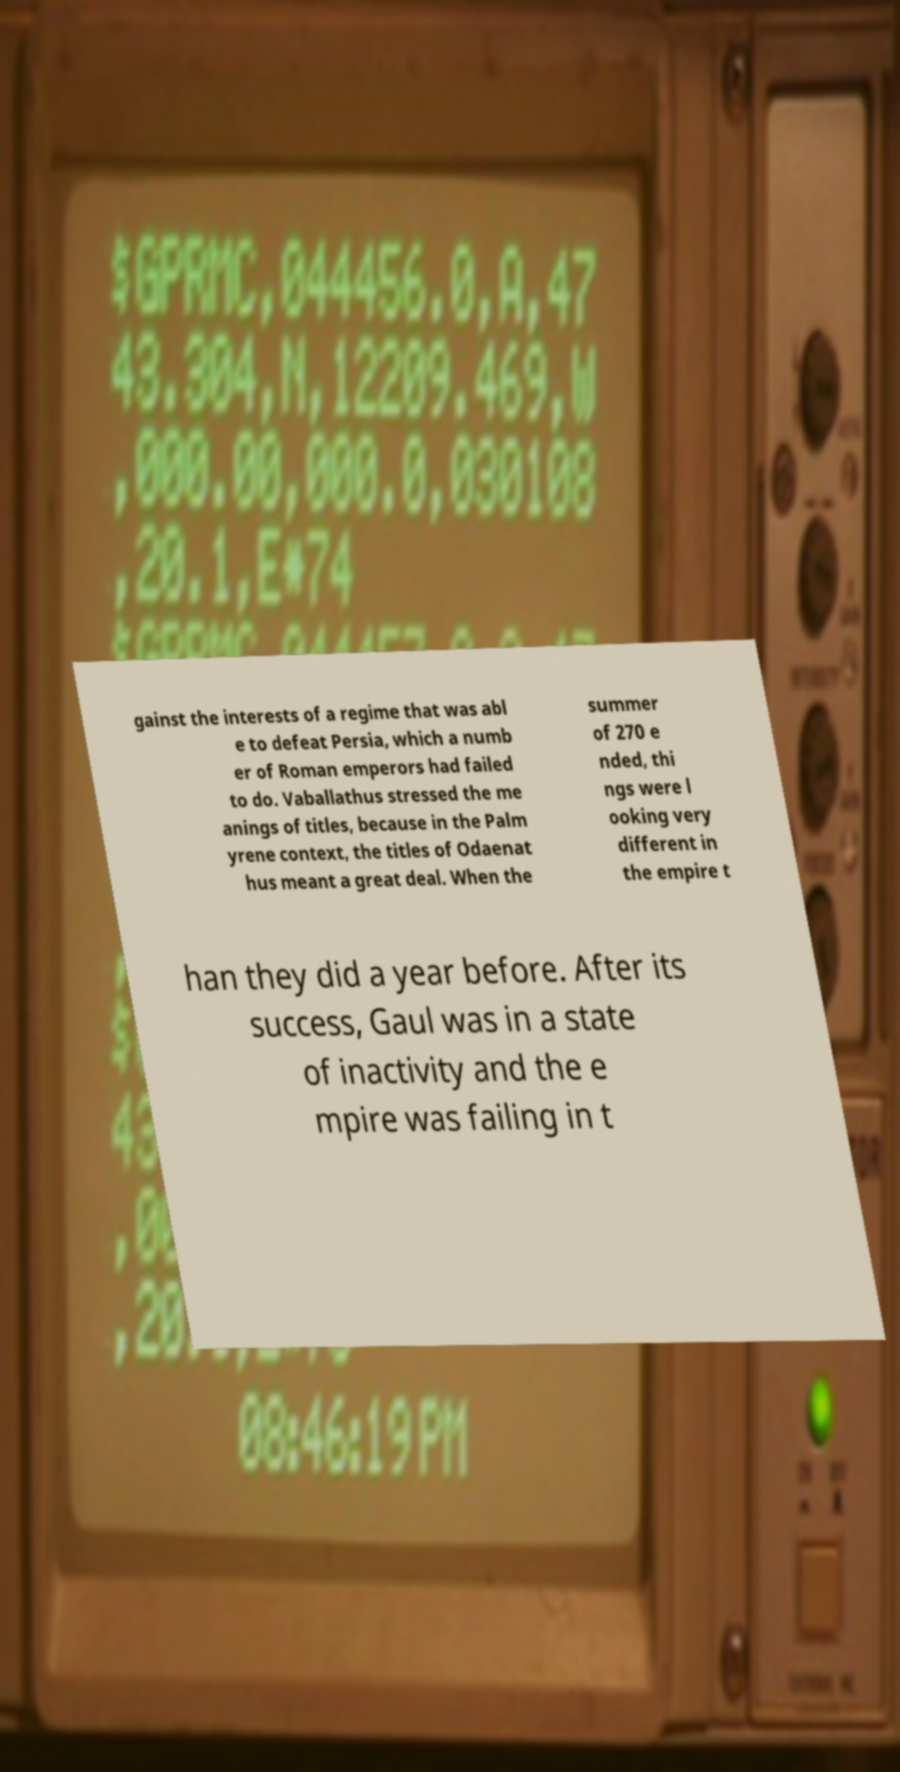I need the written content from this picture converted into text. Can you do that? gainst the interests of a regime that was abl e to defeat Persia, which a numb er of Roman emperors had failed to do. Vaballathus stressed the me anings of titles, because in the Palm yrene context, the titles of Odaenat hus meant a great deal. When the summer of 270 e nded, thi ngs were l ooking very different in the empire t han they did a year before. After its success, Gaul was in a state of inactivity and the e mpire was failing in t 